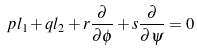Convert formula to latex. <formula><loc_0><loc_0><loc_500><loc_500>p l _ { 1 } + q l _ { 2 } + r \frac { \partial } { \partial \phi } + s \frac { \partial } { \partial \psi } = 0</formula> 